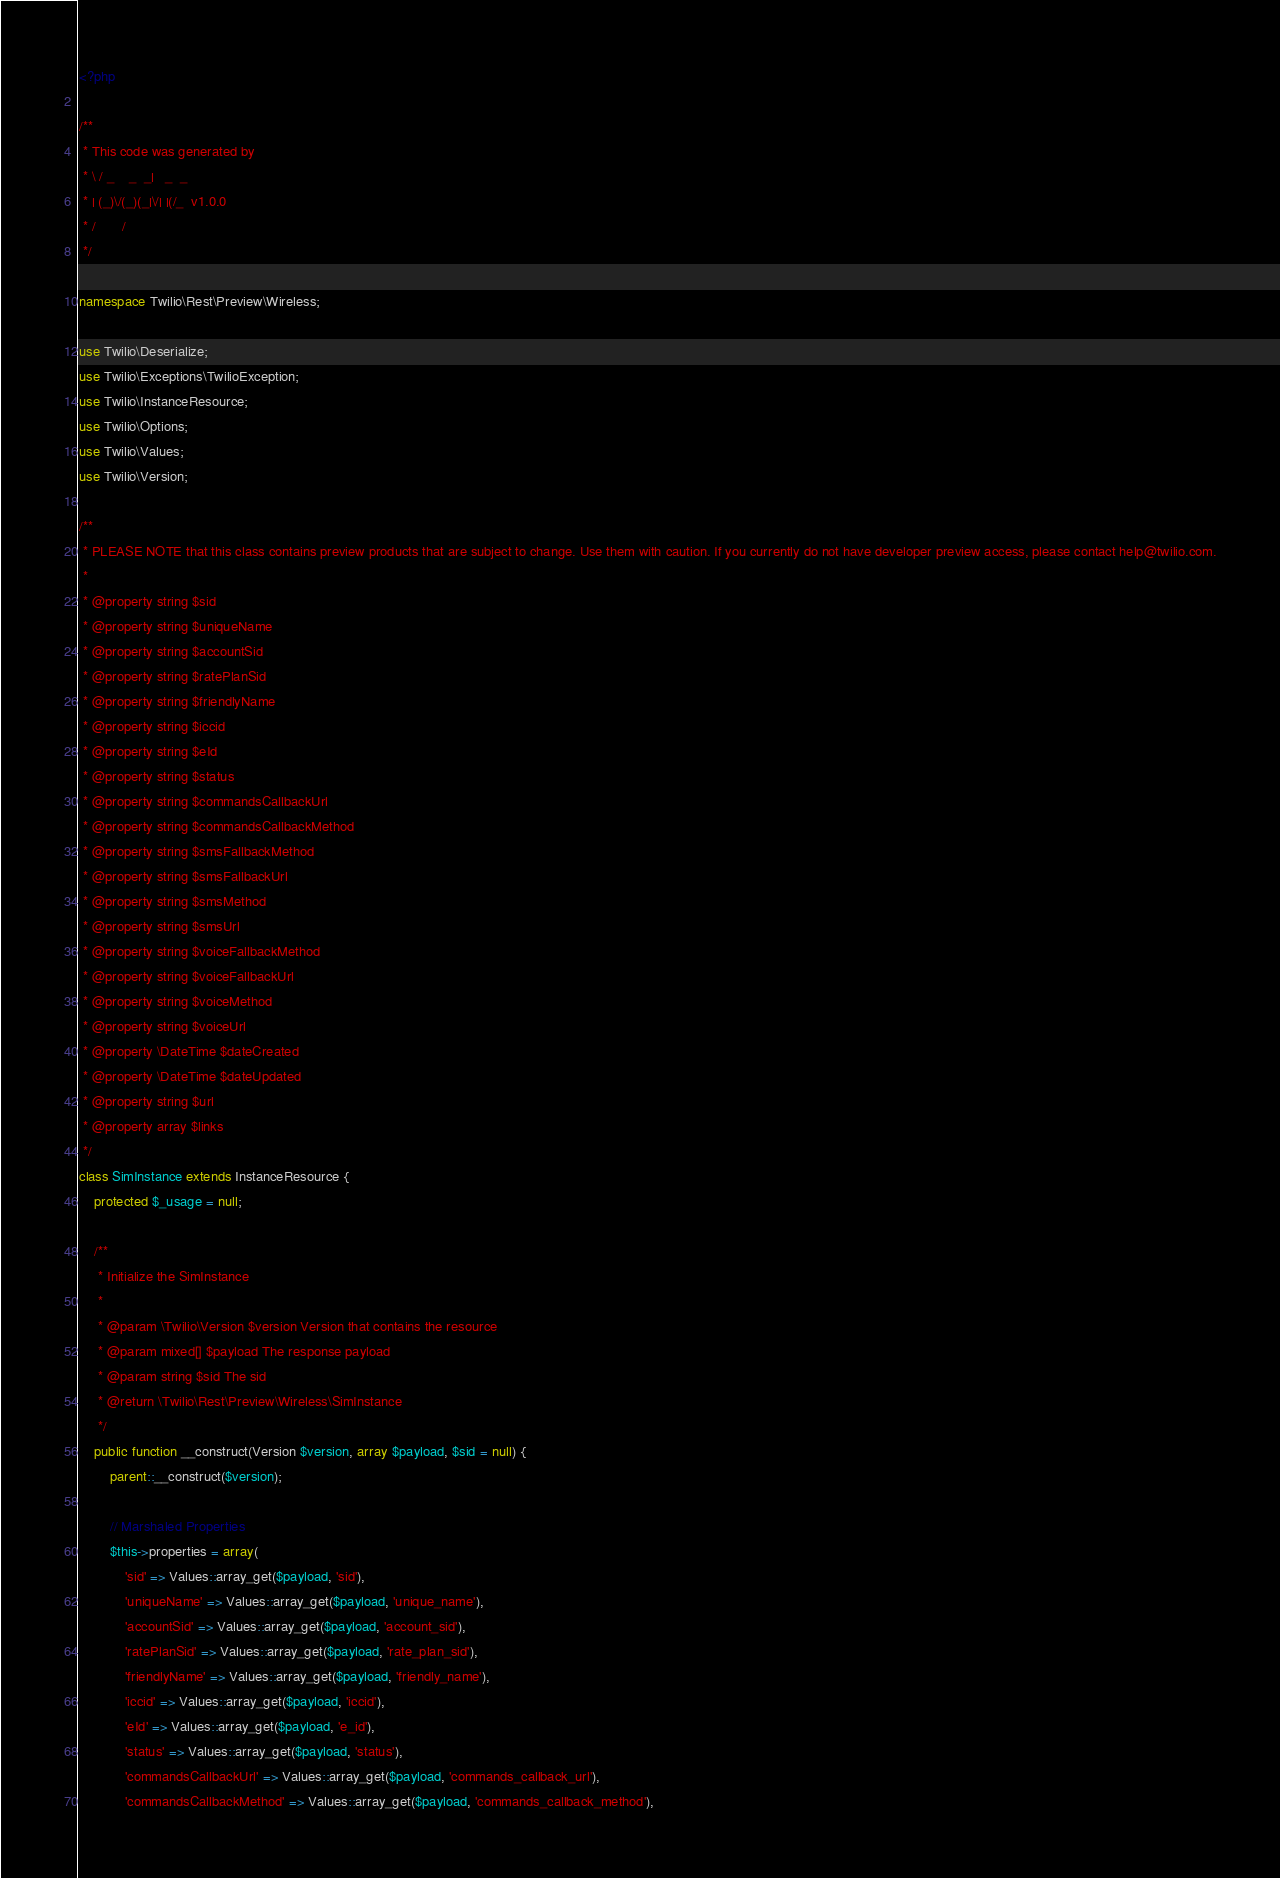Convert code to text. <code><loc_0><loc_0><loc_500><loc_500><_PHP_><?php

/**
 * This code was generated by
 * \ / _    _  _|   _  _
 * | (_)\/(_)(_|\/| |(/_  v1.0.0
 * /       /
 */

namespace Twilio\Rest\Preview\Wireless;

use Twilio\Deserialize;
use Twilio\Exceptions\TwilioException;
use Twilio\InstanceResource;
use Twilio\Options;
use Twilio\Values;
use Twilio\Version;

/**
 * PLEASE NOTE that this class contains preview products that are subject to change. Use them with caution. If you currently do not have developer preview access, please contact help@twilio.com.
 *
 * @property string $sid
 * @property string $uniqueName
 * @property string $accountSid
 * @property string $ratePlanSid
 * @property string $friendlyName
 * @property string $iccid
 * @property string $eId
 * @property string $status
 * @property string $commandsCallbackUrl
 * @property string $commandsCallbackMethod
 * @property string $smsFallbackMethod
 * @property string $smsFallbackUrl
 * @property string $smsMethod
 * @property string $smsUrl
 * @property string $voiceFallbackMethod
 * @property string $voiceFallbackUrl
 * @property string $voiceMethod
 * @property string $voiceUrl
 * @property \DateTime $dateCreated
 * @property \DateTime $dateUpdated
 * @property string $url
 * @property array $links
 */
class SimInstance extends InstanceResource {
    protected $_usage = null;

    /**
     * Initialize the SimInstance
     *
     * @param \Twilio\Version $version Version that contains the resource
     * @param mixed[] $payload The response payload
     * @param string $sid The sid
     * @return \Twilio\Rest\Preview\Wireless\SimInstance
     */
    public function __construct(Version $version, array $payload, $sid = null) {
        parent::__construct($version);

        // Marshaled Properties
        $this->properties = array(
            'sid' => Values::array_get($payload, 'sid'),
            'uniqueName' => Values::array_get($payload, 'unique_name'),
            'accountSid' => Values::array_get($payload, 'account_sid'),
            'ratePlanSid' => Values::array_get($payload, 'rate_plan_sid'),
            'friendlyName' => Values::array_get($payload, 'friendly_name'),
            'iccid' => Values::array_get($payload, 'iccid'),
            'eId' => Values::array_get($payload, 'e_id'),
            'status' => Values::array_get($payload, 'status'),
            'commandsCallbackUrl' => Values::array_get($payload, 'commands_callback_url'),
            'commandsCallbackMethod' => Values::array_get($payload, 'commands_callback_method'),</code> 